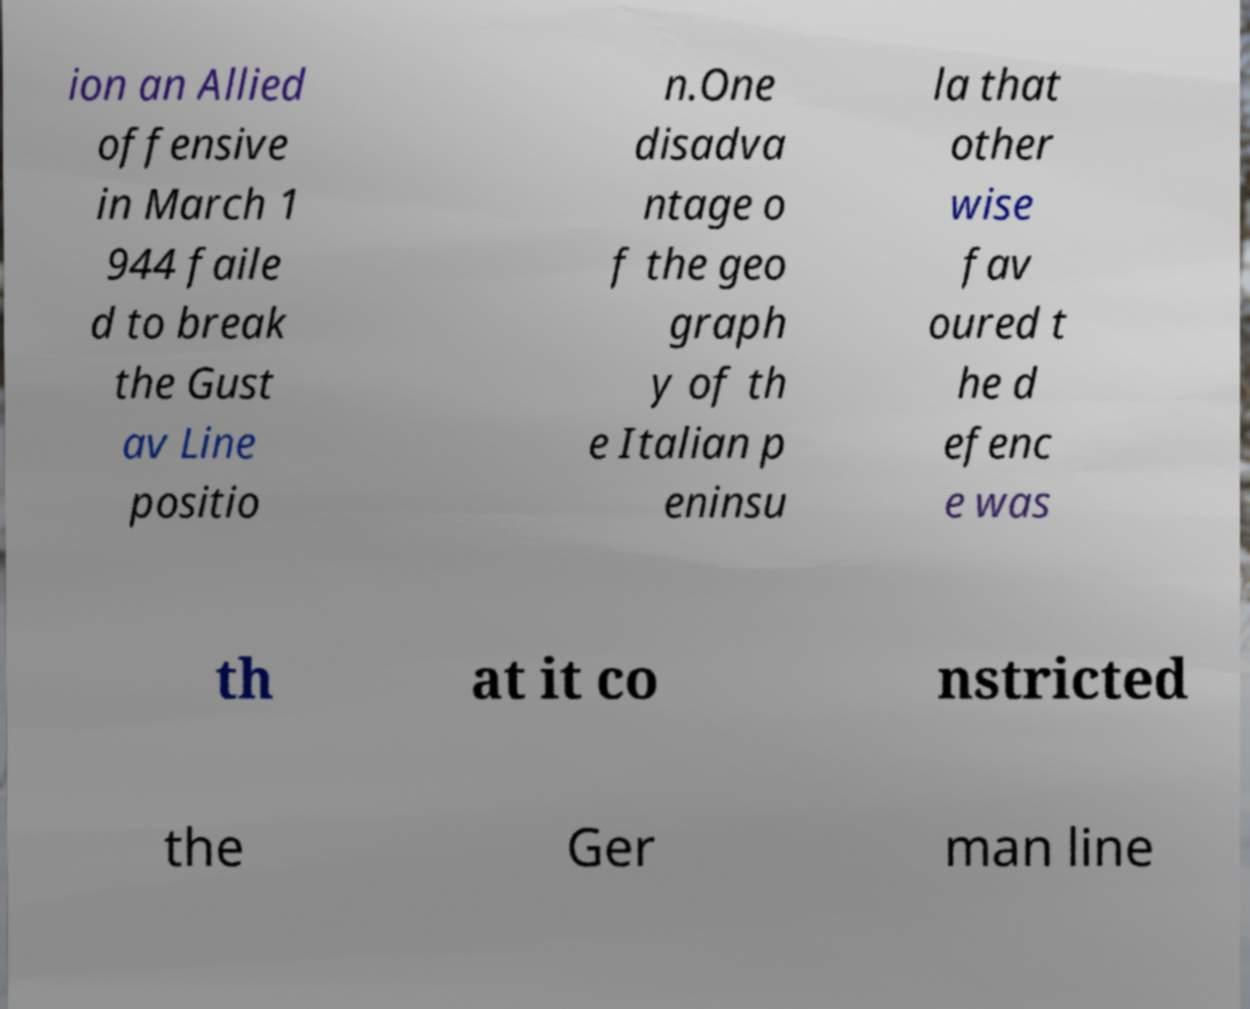For documentation purposes, I need the text within this image transcribed. Could you provide that? ion an Allied offensive in March 1 944 faile d to break the Gust av Line positio n.One disadva ntage o f the geo graph y of th e Italian p eninsu la that other wise fav oured t he d efenc e was th at it co nstricted the Ger man line 